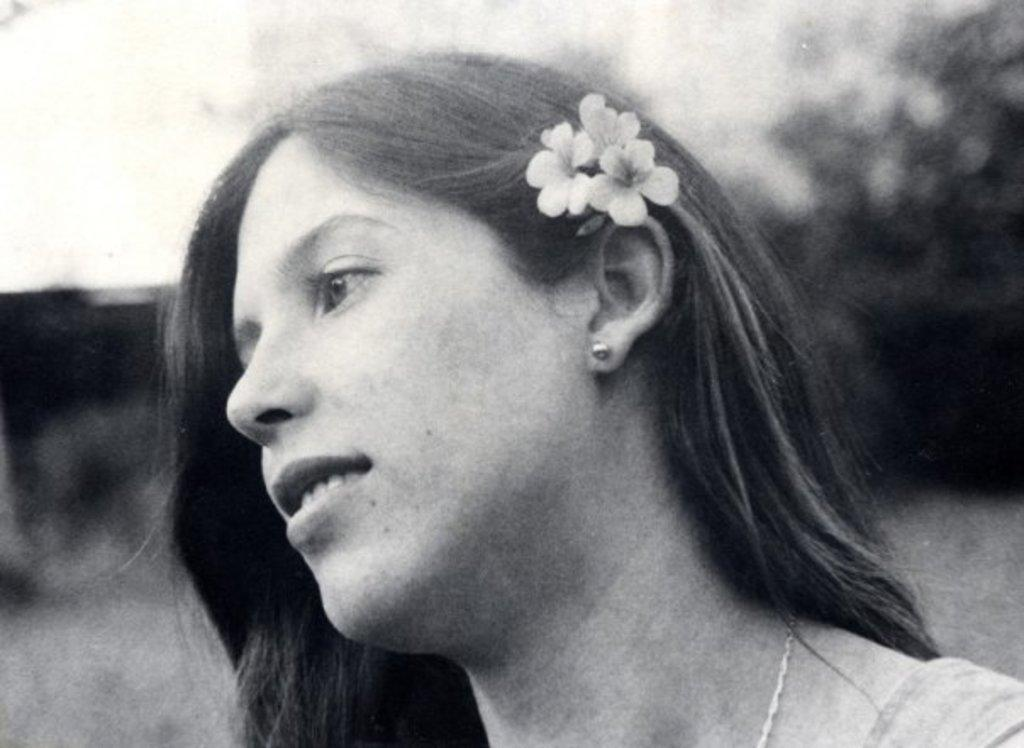What is the color scheme of the image? The image is black and white. Who is present in the image? There is a woman in the image. What is the woman holding? The woman is holding flowers. Can you describe the background of the image? The background of the image is blurred. What type of quill is the woman using to write a statement in the image? There is no quill or statement present in the image; it features a woman holding flowers against a blurred background. 